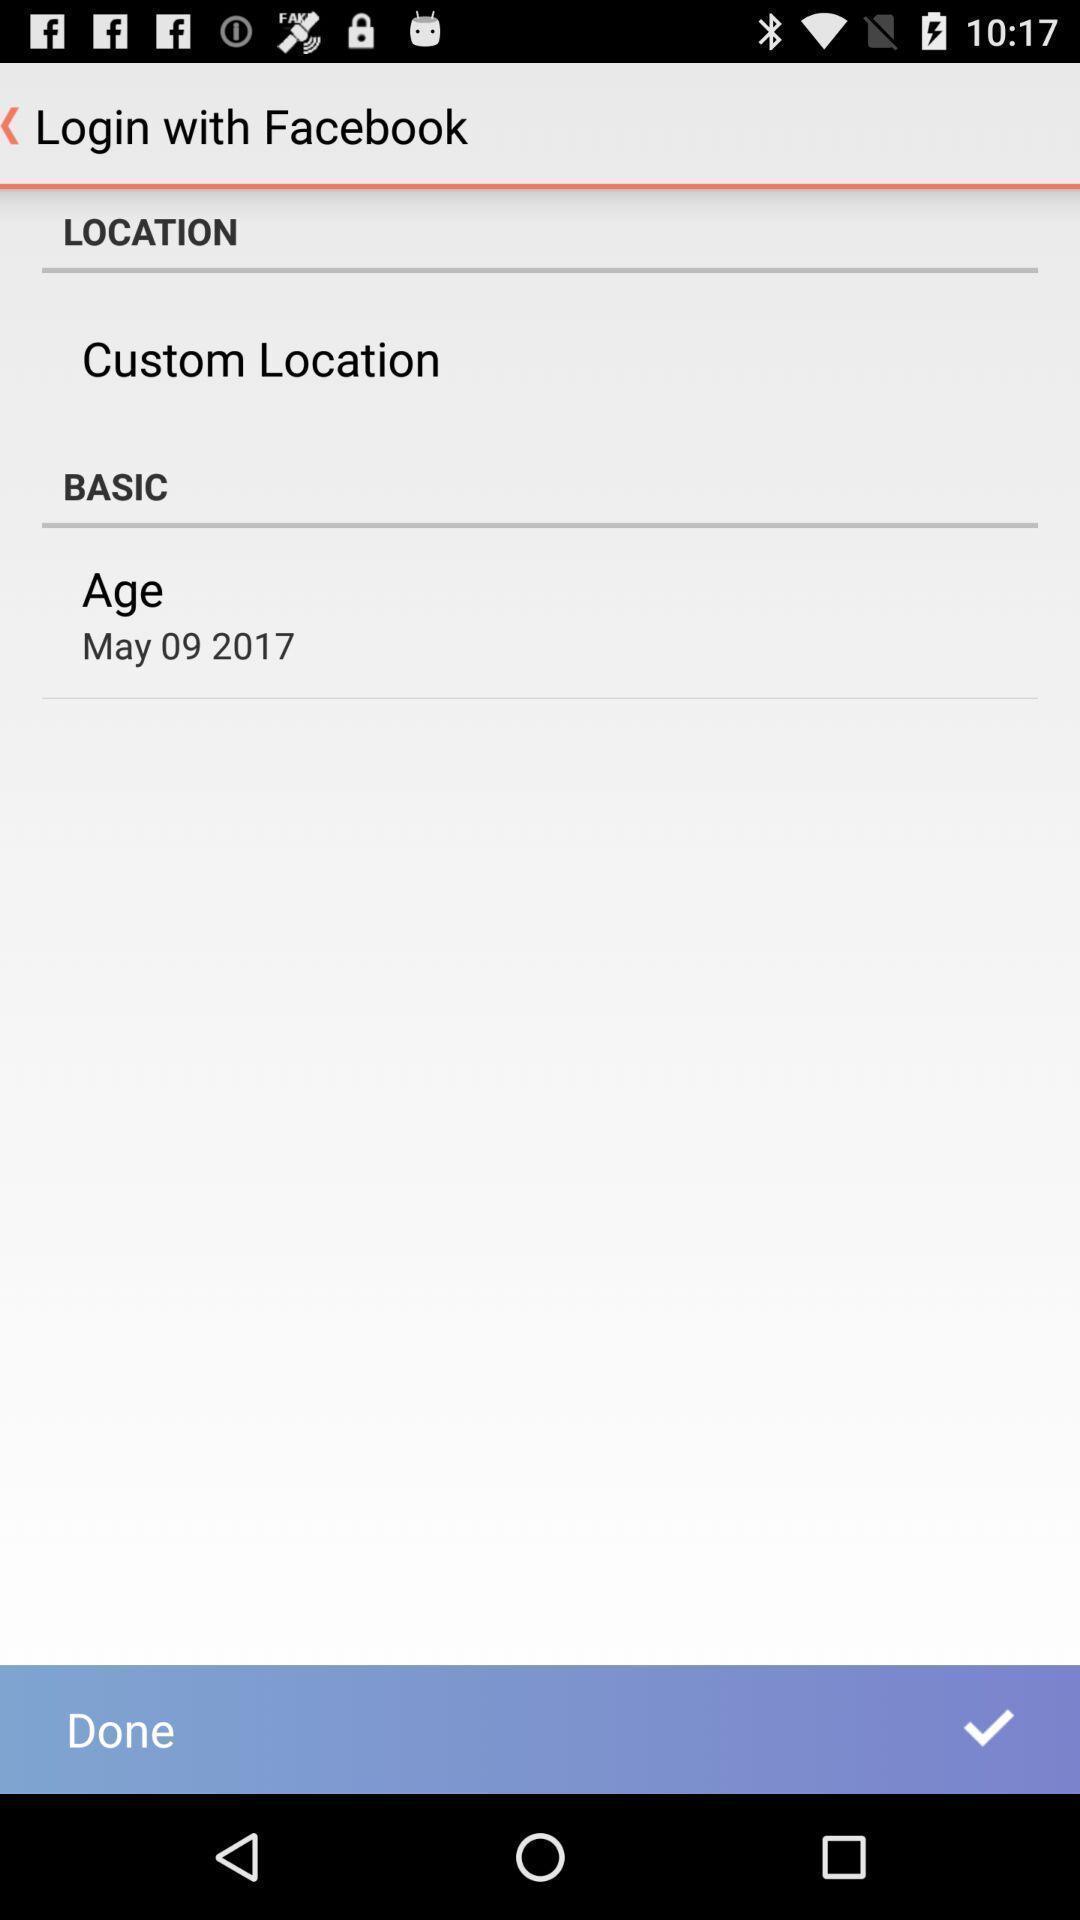Give me a narrative description of this picture. Page to add details for login. 